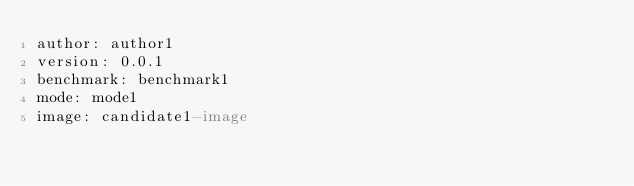<code> <loc_0><loc_0><loc_500><loc_500><_YAML_>author: author1
version: 0.0.1
benchmark: benchmark1
mode: mode1
image: candidate1-image
</code> 